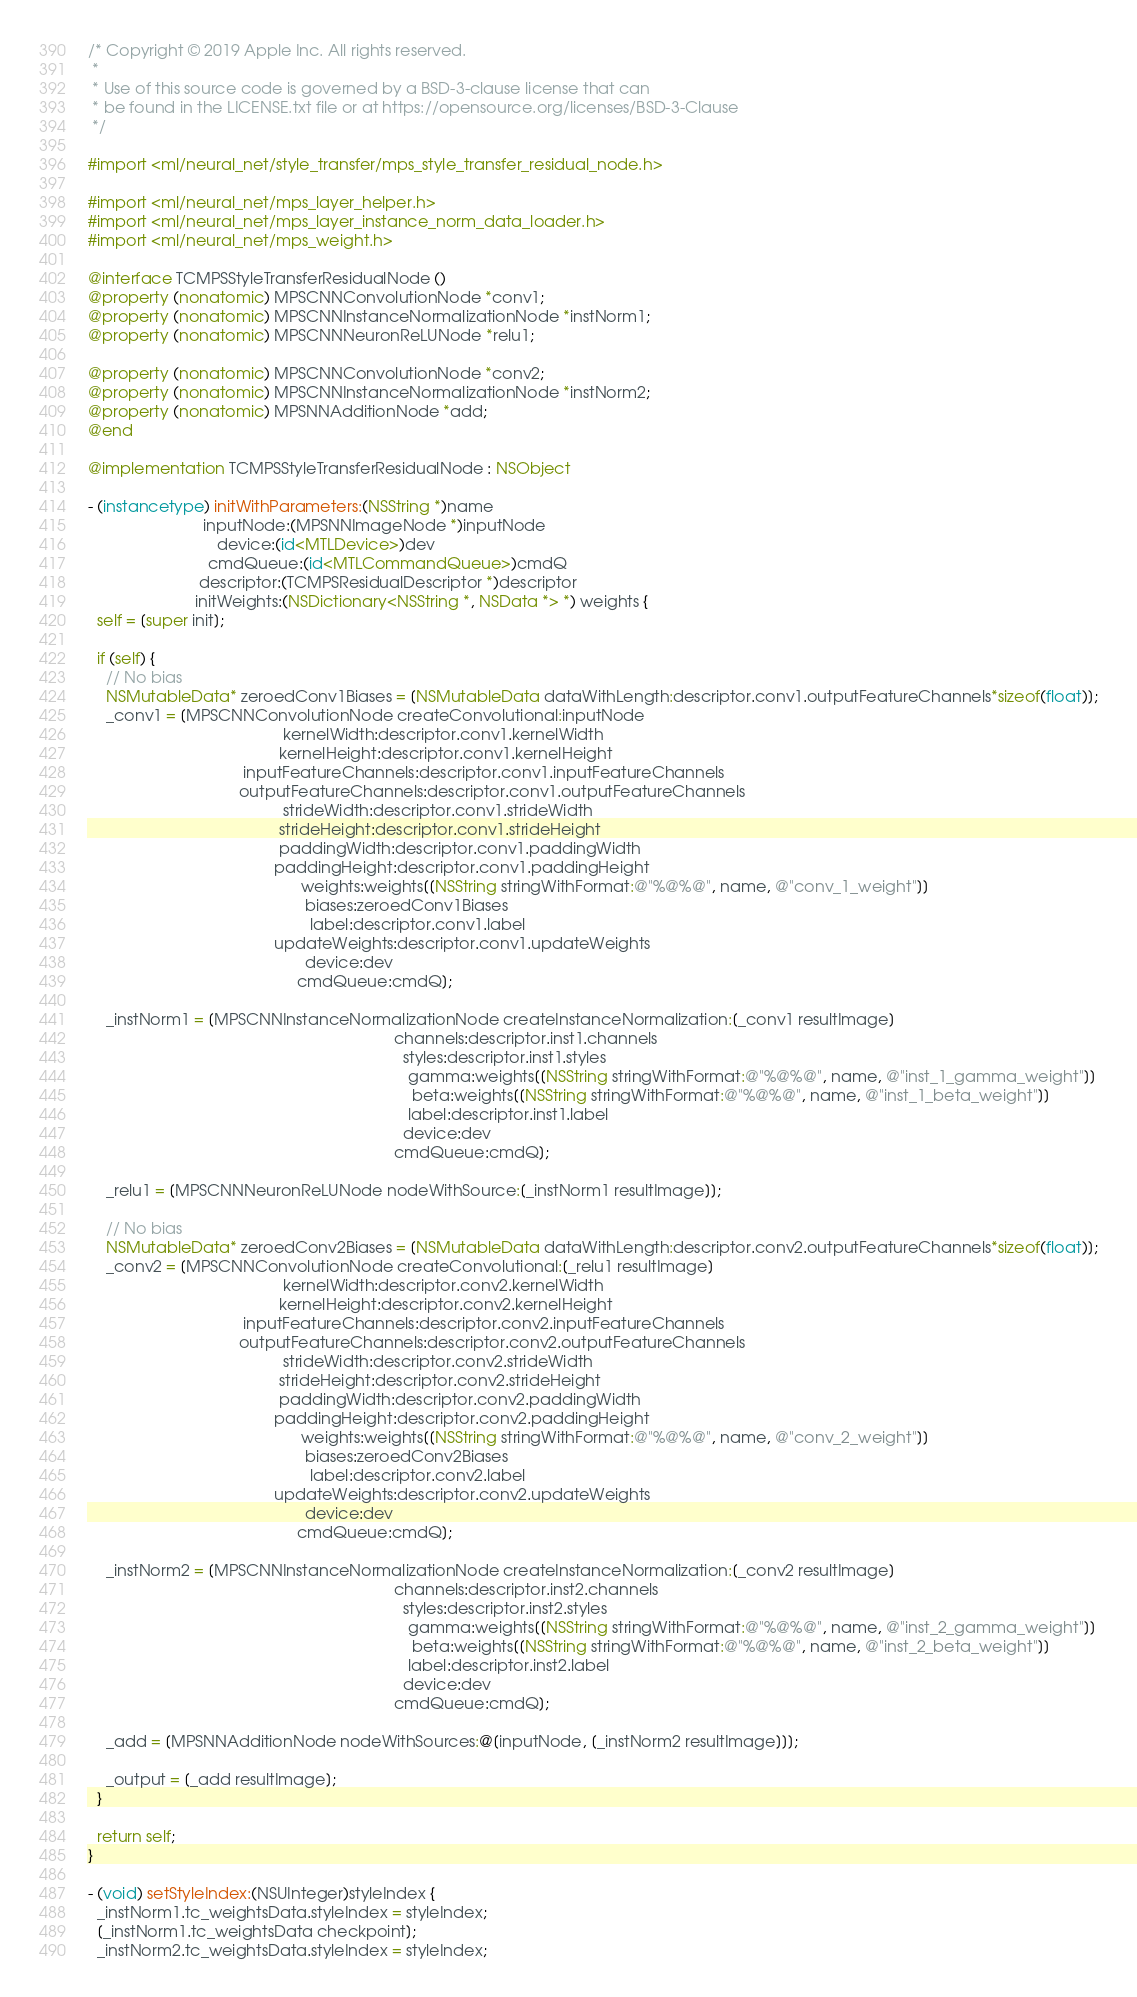<code> <loc_0><loc_0><loc_500><loc_500><_ObjectiveC_>/* Copyright © 2019 Apple Inc. All rights reserved.
 *
 * Use of this source code is governed by a BSD-3-clause license that can
 * be found in the LICENSE.txt file or at https://opensource.org/licenses/BSD-3-Clause
 */

#import <ml/neural_net/style_transfer/mps_style_transfer_residual_node.h>

#import <ml/neural_net/mps_layer_helper.h>
#import <ml/neural_net/mps_layer_instance_norm_data_loader.h>
#import <ml/neural_net/mps_weight.h>

@interface TCMPSStyleTransferResidualNode ()
@property (nonatomic) MPSCNNConvolutionNode *conv1;
@property (nonatomic) MPSCNNInstanceNormalizationNode *instNorm1;
@property (nonatomic) MPSCNNNeuronReLUNode *relu1;

@property (nonatomic) MPSCNNConvolutionNode *conv2;
@property (nonatomic) MPSCNNInstanceNormalizationNode *instNorm2;
@property (nonatomic) MPSNNAdditionNode *add;
@end

@implementation TCMPSStyleTransferResidualNode : NSObject

- (instancetype) initWithParameters:(NSString *)name
                          inputNode:(MPSNNImageNode *)inputNode
                             device:(id<MTLDevice>)dev
                           cmdQueue:(id<MTLCommandQueue>)cmdQ
                         descriptor:(TCMPSResidualDescriptor *)descriptor
                        initWeights:(NSDictionary<NSString *, NSData *> *) weights {
  self = [super init];

  if (self) {
    // No bias
    NSMutableData* zeroedConv1Biases = [NSMutableData dataWithLength:descriptor.conv1.outputFeatureChannels*sizeof(float)];
    _conv1 = [MPSCNNConvolutionNode createConvolutional:inputNode
                                            kernelWidth:descriptor.conv1.kernelWidth
                                           kernelHeight:descriptor.conv1.kernelHeight
                                   inputFeatureChannels:descriptor.conv1.inputFeatureChannels
                                  outputFeatureChannels:descriptor.conv1.outputFeatureChannels
                                            strideWidth:descriptor.conv1.strideWidth
                                           strideHeight:descriptor.conv1.strideHeight
                                           paddingWidth:descriptor.conv1.paddingWidth
                                          paddingHeight:descriptor.conv1.paddingHeight
                                                weights:weights[[NSString stringWithFormat:@"%@%@", name, @"conv_1_weight"]]
                                                 biases:zeroedConv1Biases
                                                  label:descriptor.conv1.label
                                          updateWeights:descriptor.conv1.updateWeights
                                                 device:dev
                                               cmdQueue:cmdQ];

    _instNorm1 = [MPSCNNInstanceNormalizationNode createInstanceNormalization:[_conv1 resultImage]
                                                                     channels:descriptor.inst1.channels
                                                                       styles:descriptor.inst1.styles
                                                                        gamma:weights[[NSString stringWithFormat:@"%@%@", name, @"inst_1_gamma_weight"]]
                                                                         beta:weights[[NSString stringWithFormat:@"%@%@", name, @"inst_1_beta_weight"]]
                                                                        label:descriptor.inst1.label
                                                                       device:dev
                                                                     cmdQueue:cmdQ];

    _relu1 = [MPSCNNNeuronReLUNode nodeWithSource:[_instNorm1 resultImage]];

    // No bias
    NSMutableData* zeroedConv2Biases = [NSMutableData dataWithLength:descriptor.conv2.outputFeatureChannels*sizeof(float)];
    _conv2 = [MPSCNNConvolutionNode createConvolutional:[_relu1 resultImage]
                                            kernelWidth:descriptor.conv2.kernelWidth
                                           kernelHeight:descriptor.conv2.kernelHeight
                                   inputFeatureChannels:descriptor.conv2.inputFeatureChannels
                                  outputFeatureChannels:descriptor.conv2.outputFeatureChannels
                                            strideWidth:descriptor.conv2.strideWidth
                                           strideHeight:descriptor.conv2.strideHeight
                                           paddingWidth:descriptor.conv2.paddingWidth
                                          paddingHeight:descriptor.conv2.paddingHeight
                                                weights:weights[[NSString stringWithFormat:@"%@%@", name, @"conv_2_weight"]]
                                                 biases:zeroedConv2Biases
                                                  label:descriptor.conv2.label
                                          updateWeights:descriptor.conv2.updateWeights
                                                 device:dev
                                               cmdQueue:cmdQ];

    _instNorm2 = [MPSCNNInstanceNormalizationNode createInstanceNormalization:[_conv2 resultImage]
                                                                     channels:descriptor.inst2.channels
                                                                       styles:descriptor.inst2.styles
                                                                        gamma:weights[[NSString stringWithFormat:@"%@%@", name, @"inst_2_gamma_weight"]]
                                                                         beta:weights[[NSString stringWithFormat:@"%@%@", name, @"inst_2_beta_weight"]]
                                                                        label:descriptor.inst2.label
                                                                       device:dev
                                                                     cmdQueue:cmdQ]; 

    _add = [MPSNNAdditionNode nodeWithSources:@[inputNode, [_instNorm2 resultImage]]];

    _output = [_add resultImage];
  }

  return self;
}

- (void) setStyleIndex:(NSUInteger)styleIndex {
  _instNorm1.tc_weightsData.styleIndex = styleIndex;
  [_instNorm1.tc_weightsData checkpoint];
  _instNorm2.tc_weightsData.styleIndex = styleIndex;</code> 